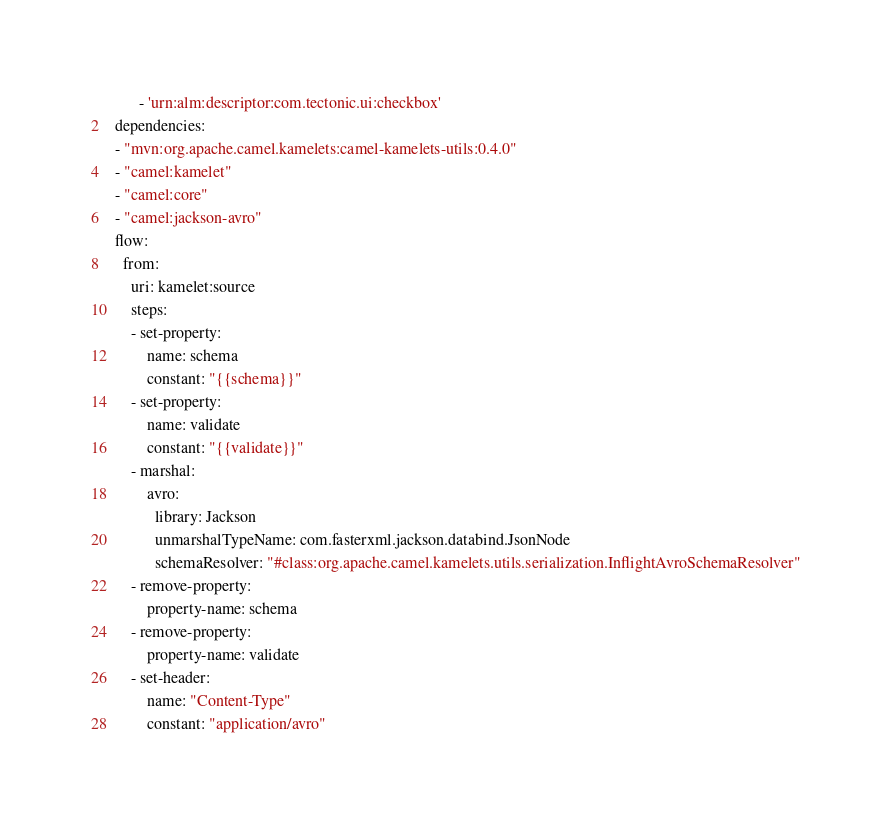Convert code to text. <code><loc_0><loc_0><loc_500><loc_500><_YAML_>        - 'urn:alm:descriptor:com.tectonic.ui:checkbox'
  dependencies:
  - "mvn:org.apache.camel.kamelets:camel-kamelets-utils:0.4.0"
  - "camel:kamelet"
  - "camel:core"
  - "camel:jackson-avro"
  flow:
    from:
      uri: kamelet:source
      steps:
      - set-property:
          name: schema
          constant: "{{schema}}"
      - set-property:
          name: validate
          constant: "{{validate}}"
      - marshal:
          avro:
            library: Jackson
            unmarshalTypeName: com.fasterxml.jackson.databind.JsonNode
            schemaResolver: "#class:org.apache.camel.kamelets.utils.serialization.InflightAvroSchemaResolver"
      - remove-property:
          property-name: schema
      - remove-property:
          property-name: validate
      - set-header:
          name: "Content-Type"
          constant: "application/avro"
</code> 